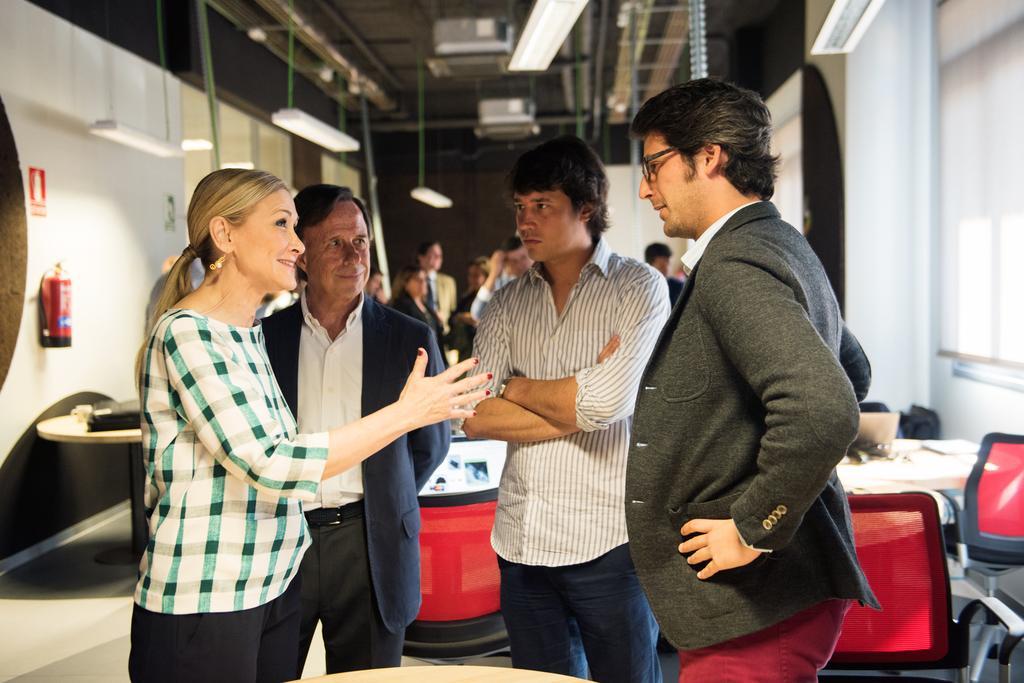In one or two sentences, can you explain what this image depicts? In this picture we can see 4 people talking and looking at each other. In the background, we see tables, chairs and other people. 